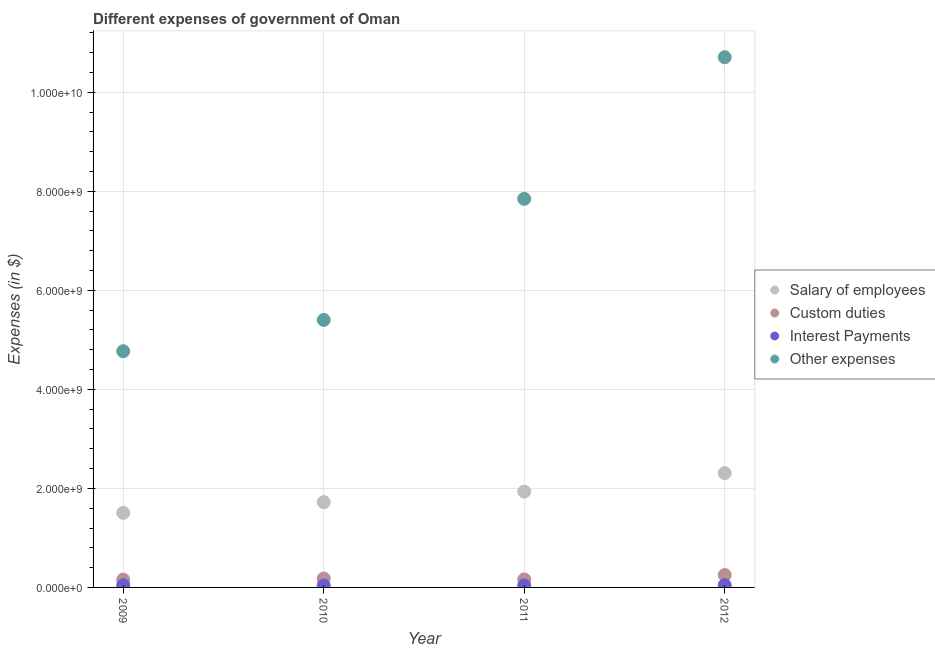How many different coloured dotlines are there?
Ensure brevity in your answer.  4. Is the number of dotlines equal to the number of legend labels?
Provide a succinct answer. Yes. What is the amount spent on custom duties in 2010?
Provide a succinct answer. 1.80e+08. Across all years, what is the maximum amount spent on interest payments?
Your answer should be compact. 4.53e+07. Across all years, what is the minimum amount spent on interest payments?
Your response must be concise. 3.74e+07. What is the total amount spent on salary of employees in the graph?
Provide a short and direct response. 7.47e+09. What is the difference between the amount spent on custom duties in 2011 and that in 2012?
Ensure brevity in your answer.  -8.89e+07. What is the difference between the amount spent on salary of employees in 2011 and the amount spent on custom duties in 2010?
Provide a short and direct response. 1.76e+09. What is the average amount spent on salary of employees per year?
Provide a succinct answer. 1.87e+09. In the year 2011, what is the difference between the amount spent on interest payments and amount spent on other expenses?
Your response must be concise. -7.81e+09. What is the ratio of the amount spent on salary of employees in 2009 to that in 2010?
Give a very brief answer. 0.87. What is the difference between the highest and the second highest amount spent on other expenses?
Provide a succinct answer. 2.86e+09. What is the difference between the highest and the lowest amount spent on salary of employees?
Your response must be concise. 8.01e+08. Is it the case that in every year, the sum of the amount spent on other expenses and amount spent on salary of employees is greater than the sum of amount spent on custom duties and amount spent on interest payments?
Your response must be concise. Yes. Is it the case that in every year, the sum of the amount spent on salary of employees and amount spent on custom duties is greater than the amount spent on interest payments?
Your answer should be very brief. Yes. Does the amount spent on interest payments monotonically increase over the years?
Offer a terse response. No. Is the amount spent on custom duties strictly greater than the amount spent on salary of employees over the years?
Provide a succinct answer. No. Is the amount spent on custom duties strictly less than the amount spent on salary of employees over the years?
Give a very brief answer. Yes. How many dotlines are there?
Make the answer very short. 4. What is the difference between two consecutive major ticks on the Y-axis?
Your answer should be compact. 2.00e+09. Are the values on the major ticks of Y-axis written in scientific E-notation?
Ensure brevity in your answer.  Yes. Does the graph contain any zero values?
Offer a terse response. No. Where does the legend appear in the graph?
Your answer should be very brief. Center right. How are the legend labels stacked?
Offer a very short reply. Vertical. What is the title of the graph?
Give a very brief answer. Different expenses of government of Oman. Does "Others" appear as one of the legend labels in the graph?
Your answer should be very brief. No. What is the label or title of the X-axis?
Ensure brevity in your answer.  Year. What is the label or title of the Y-axis?
Make the answer very short. Expenses (in $). What is the Expenses (in $) in Salary of employees in 2009?
Your answer should be compact. 1.51e+09. What is the Expenses (in $) in Custom duties in 2009?
Provide a succinct answer. 1.58e+08. What is the Expenses (in $) of Interest Payments in 2009?
Provide a short and direct response. 4.50e+07. What is the Expenses (in $) of Other expenses in 2009?
Keep it short and to the point. 4.77e+09. What is the Expenses (in $) in Salary of employees in 2010?
Give a very brief answer. 1.72e+09. What is the Expenses (in $) of Custom duties in 2010?
Your answer should be compact. 1.80e+08. What is the Expenses (in $) in Interest Payments in 2010?
Your answer should be compact. 3.74e+07. What is the Expenses (in $) of Other expenses in 2010?
Make the answer very short. 5.40e+09. What is the Expenses (in $) in Salary of employees in 2011?
Your answer should be compact. 1.94e+09. What is the Expenses (in $) in Custom duties in 2011?
Ensure brevity in your answer.  1.61e+08. What is the Expenses (in $) in Interest Payments in 2011?
Provide a short and direct response. 3.81e+07. What is the Expenses (in $) of Other expenses in 2011?
Give a very brief answer. 7.85e+09. What is the Expenses (in $) in Salary of employees in 2012?
Make the answer very short. 2.31e+09. What is the Expenses (in $) in Custom duties in 2012?
Your answer should be compact. 2.50e+08. What is the Expenses (in $) in Interest Payments in 2012?
Offer a very short reply. 4.53e+07. What is the Expenses (in $) of Other expenses in 2012?
Offer a very short reply. 1.07e+1. Across all years, what is the maximum Expenses (in $) of Salary of employees?
Keep it short and to the point. 2.31e+09. Across all years, what is the maximum Expenses (in $) of Custom duties?
Offer a terse response. 2.50e+08. Across all years, what is the maximum Expenses (in $) of Interest Payments?
Keep it short and to the point. 4.53e+07. Across all years, what is the maximum Expenses (in $) of Other expenses?
Your response must be concise. 1.07e+1. Across all years, what is the minimum Expenses (in $) in Salary of employees?
Your answer should be very brief. 1.51e+09. Across all years, what is the minimum Expenses (in $) in Custom duties?
Provide a short and direct response. 1.58e+08. Across all years, what is the minimum Expenses (in $) of Interest Payments?
Give a very brief answer. 3.74e+07. Across all years, what is the minimum Expenses (in $) in Other expenses?
Make the answer very short. 4.77e+09. What is the total Expenses (in $) of Salary of employees in the graph?
Your answer should be very brief. 7.47e+09. What is the total Expenses (in $) of Custom duties in the graph?
Give a very brief answer. 7.49e+08. What is the total Expenses (in $) in Interest Payments in the graph?
Keep it short and to the point. 1.66e+08. What is the total Expenses (in $) in Other expenses in the graph?
Offer a terse response. 2.87e+1. What is the difference between the Expenses (in $) of Salary of employees in 2009 and that in 2010?
Your answer should be compact. -2.16e+08. What is the difference between the Expenses (in $) in Custom duties in 2009 and that in 2010?
Make the answer very short. -2.15e+07. What is the difference between the Expenses (in $) of Interest Payments in 2009 and that in 2010?
Offer a very short reply. 7.60e+06. What is the difference between the Expenses (in $) in Other expenses in 2009 and that in 2010?
Ensure brevity in your answer.  -6.32e+08. What is the difference between the Expenses (in $) in Salary of employees in 2009 and that in 2011?
Keep it short and to the point. -4.29e+08. What is the difference between the Expenses (in $) in Custom duties in 2009 and that in 2011?
Your answer should be very brief. -3.10e+06. What is the difference between the Expenses (in $) of Interest Payments in 2009 and that in 2011?
Keep it short and to the point. 6.90e+06. What is the difference between the Expenses (in $) of Other expenses in 2009 and that in 2011?
Make the answer very short. -3.08e+09. What is the difference between the Expenses (in $) of Salary of employees in 2009 and that in 2012?
Make the answer very short. -8.01e+08. What is the difference between the Expenses (in $) in Custom duties in 2009 and that in 2012?
Your response must be concise. -9.20e+07. What is the difference between the Expenses (in $) of Other expenses in 2009 and that in 2012?
Provide a short and direct response. -5.94e+09. What is the difference between the Expenses (in $) in Salary of employees in 2010 and that in 2011?
Offer a very short reply. -2.13e+08. What is the difference between the Expenses (in $) in Custom duties in 2010 and that in 2011?
Make the answer very short. 1.84e+07. What is the difference between the Expenses (in $) in Interest Payments in 2010 and that in 2011?
Ensure brevity in your answer.  -7.00e+05. What is the difference between the Expenses (in $) in Other expenses in 2010 and that in 2011?
Make the answer very short. -2.45e+09. What is the difference between the Expenses (in $) of Salary of employees in 2010 and that in 2012?
Offer a terse response. -5.85e+08. What is the difference between the Expenses (in $) of Custom duties in 2010 and that in 2012?
Your response must be concise. -7.05e+07. What is the difference between the Expenses (in $) of Interest Payments in 2010 and that in 2012?
Your answer should be very brief. -7.90e+06. What is the difference between the Expenses (in $) in Other expenses in 2010 and that in 2012?
Ensure brevity in your answer.  -5.30e+09. What is the difference between the Expenses (in $) of Salary of employees in 2011 and that in 2012?
Provide a succinct answer. -3.72e+08. What is the difference between the Expenses (in $) in Custom duties in 2011 and that in 2012?
Offer a very short reply. -8.89e+07. What is the difference between the Expenses (in $) in Interest Payments in 2011 and that in 2012?
Provide a succinct answer. -7.20e+06. What is the difference between the Expenses (in $) in Other expenses in 2011 and that in 2012?
Offer a very short reply. -2.86e+09. What is the difference between the Expenses (in $) in Salary of employees in 2009 and the Expenses (in $) in Custom duties in 2010?
Offer a very short reply. 1.33e+09. What is the difference between the Expenses (in $) of Salary of employees in 2009 and the Expenses (in $) of Interest Payments in 2010?
Provide a short and direct response. 1.47e+09. What is the difference between the Expenses (in $) of Salary of employees in 2009 and the Expenses (in $) of Other expenses in 2010?
Make the answer very short. -3.90e+09. What is the difference between the Expenses (in $) in Custom duties in 2009 and the Expenses (in $) in Interest Payments in 2010?
Your answer should be compact. 1.21e+08. What is the difference between the Expenses (in $) of Custom duties in 2009 and the Expenses (in $) of Other expenses in 2010?
Your answer should be very brief. -5.24e+09. What is the difference between the Expenses (in $) of Interest Payments in 2009 and the Expenses (in $) of Other expenses in 2010?
Your answer should be compact. -5.36e+09. What is the difference between the Expenses (in $) of Salary of employees in 2009 and the Expenses (in $) of Custom duties in 2011?
Your answer should be compact. 1.35e+09. What is the difference between the Expenses (in $) of Salary of employees in 2009 and the Expenses (in $) of Interest Payments in 2011?
Offer a very short reply. 1.47e+09. What is the difference between the Expenses (in $) of Salary of employees in 2009 and the Expenses (in $) of Other expenses in 2011?
Your response must be concise. -6.34e+09. What is the difference between the Expenses (in $) of Custom duties in 2009 and the Expenses (in $) of Interest Payments in 2011?
Provide a short and direct response. 1.20e+08. What is the difference between the Expenses (in $) of Custom duties in 2009 and the Expenses (in $) of Other expenses in 2011?
Provide a succinct answer. -7.69e+09. What is the difference between the Expenses (in $) of Interest Payments in 2009 and the Expenses (in $) of Other expenses in 2011?
Your answer should be very brief. -7.80e+09. What is the difference between the Expenses (in $) in Salary of employees in 2009 and the Expenses (in $) in Custom duties in 2012?
Keep it short and to the point. 1.26e+09. What is the difference between the Expenses (in $) of Salary of employees in 2009 and the Expenses (in $) of Interest Payments in 2012?
Offer a very short reply. 1.46e+09. What is the difference between the Expenses (in $) in Salary of employees in 2009 and the Expenses (in $) in Other expenses in 2012?
Your response must be concise. -9.20e+09. What is the difference between the Expenses (in $) in Custom duties in 2009 and the Expenses (in $) in Interest Payments in 2012?
Offer a very short reply. 1.13e+08. What is the difference between the Expenses (in $) of Custom duties in 2009 and the Expenses (in $) of Other expenses in 2012?
Your answer should be very brief. -1.05e+1. What is the difference between the Expenses (in $) in Interest Payments in 2009 and the Expenses (in $) in Other expenses in 2012?
Keep it short and to the point. -1.07e+1. What is the difference between the Expenses (in $) in Salary of employees in 2010 and the Expenses (in $) in Custom duties in 2011?
Provide a short and direct response. 1.56e+09. What is the difference between the Expenses (in $) in Salary of employees in 2010 and the Expenses (in $) in Interest Payments in 2011?
Offer a terse response. 1.68e+09. What is the difference between the Expenses (in $) of Salary of employees in 2010 and the Expenses (in $) of Other expenses in 2011?
Make the answer very short. -6.12e+09. What is the difference between the Expenses (in $) in Custom duties in 2010 and the Expenses (in $) in Interest Payments in 2011?
Your response must be concise. 1.42e+08. What is the difference between the Expenses (in $) in Custom duties in 2010 and the Expenses (in $) in Other expenses in 2011?
Keep it short and to the point. -7.67e+09. What is the difference between the Expenses (in $) in Interest Payments in 2010 and the Expenses (in $) in Other expenses in 2011?
Offer a terse response. -7.81e+09. What is the difference between the Expenses (in $) in Salary of employees in 2010 and the Expenses (in $) in Custom duties in 2012?
Your answer should be compact. 1.47e+09. What is the difference between the Expenses (in $) in Salary of employees in 2010 and the Expenses (in $) in Interest Payments in 2012?
Offer a terse response. 1.68e+09. What is the difference between the Expenses (in $) in Salary of employees in 2010 and the Expenses (in $) in Other expenses in 2012?
Your answer should be very brief. -8.98e+09. What is the difference between the Expenses (in $) in Custom duties in 2010 and the Expenses (in $) in Interest Payments in 2012?
Provide a short and direct response. 1.34e+08. What is the difference between the Expenses (in $) in Custom duties in 2010 and the Expenses (in $) in Other expenses in 2012?
Make the answer very short. -1.05e+1. What is the difference between the Expenses (in $) of Interest Payments in 2010 and the Expenses (in $) of Other expenses in 2012?
Make the answer very short. -1.07e+1. What is the difference between the Expenses (in $) in Salary of employees in 2011 and the Expenses (in $) in Custom duties in 2012?
Your answer should be very brief. 1.69e+09. What is the difference between the Expenses (in $) of Salary of employees in 2011 and the Expenses (in $) of Interest Payments in 2012?
Keep it short and to the point. 1.89e+09. What is the difference between the Expenses (in $) in Salary of employees in 2011 and the Expenses (in $) in Other expenses in 2012?
Your response must be concise. -8.77e+09. What is the difference between the Expenses (in $) of Custom duties in 2011 and the Expenses (in $) of Interest Payments in 2012?
Your response must be concise. 1.16e+08. What is the difference between the Expenses (in $) of Custom duties in 2011 and the Expenses (in $) of Other expenses in 2012?
Ensure brevity in your answer.  -1.05e+1. What is the difference between the Expenses (in $) in Interest Payments in 2011 and the Expenses (in $) in Other expenses in 2012?
Make the answer very short. -1.07e+1. What is the average Expenses (in $) of Salary of employees per year?
Make the answer very short. 1.87e+09. What is the average Expenses (in $) in Custom duties per year?
Keep it short and to the point. 1.87e+08. What is the average Expenses (in $) in Interest Payments per year?
Your answer should be very brief. 4.14e+07. What is the average Expenses (in $) of Other expenses per year?
Ensure brevity in your answer.  7.18e+09. In the year 2009, what is the difference between the Expenses (in $) in Salary of employees and Expenses (in $) in Custom duties?
Keep it short and to the point. 1.35e+09. In the year 2009, what is the difference between the Expenses (in $) in Salary of employees and Expenses (in $) in Interest Payments?
Ensure brevity in your answer.  1.46e+09. In the year 2009, what is the difference between the Expenses (in $) of Salary of employees and Expenses (in $) of Other expenses?
Provide a succinct answer. -3.26e+09. In the year 2009, what is the difference between the Expenses (in $) of Custom duties and Expenses (in $) of Interest Payments?
Give a very brief answer. 1.13e+08. In the year 2009, what is the difference between the Expenses (in $) of Custom duties and Expenses (in $) of Other expenses?
Give a very brief answer. -4.61e+09. In the year 2009, what is the difference between the Expenses (in $) of Interest Payments and Expenses (in $) of Other expenses?
Ensure brevity in your answer.  -4.73e+09. In the year 2010, what is the difference between the Expenses (in $) in Salary of employees and Expenses (in $) in Custom duties?
Make the answer very short. 1.54e+09. In the year 2010, what is the difference between the Expenses (in $) of Salary of employees and Expenses (in $) of Interest Payments?
Provide a short and direct response. 1.69e+09. In the year 2010, what is the difference between the Expenses (in $) in Salary of employees and Expenses (in $) in Other expenses?
Offer a very short reply. -3.68e+09. In the year 2010, what is the difference between the Expenses (in $) of Custom duties and Expenses (in $) of Interest Payments?
Ensure brevity in your answer.  1.42e+08. In the year 2010, what is the difference between the Expenses (in $) of Custom duties and Expenses (in $) of Other expenses?
Offer a terse response. -5.22e+09. In the year 2010, what is the difference between the Expenses (in $) of Interest Payments and Expenses (in $) of Other expenses?
Provide a short and direct response. -5.36e+09. In the year 2011, what is the difference between the Expenses (in $) in Salary of employees and Expenses (in $) in Custom duties?
Provide a succinct answer. 1.77e+09. In the year 2011, what is the difference between the Expenses (in $) in Salary of employees and Expenses (in $) in Interest Payments?
Make the answer very short. 1.90e+09. In the year 2011, what is the difference between the Expenses (in $) of Salary of employees and Expenses (in $) of Other expenses?
Your answer should be compact. -5.91e+09. In the year 2011, what is the difference between the Expenses (in $) in Custom duties and Expenses (in $) in Interest Payments?
Your response must be concise. 1.23e+08. In the year 2011, what is the difference between the Expenses (in $) in Custom duties and Expenses (in $) in Other expenses?
Give a very brief answer. -7.69e+09. In the year 2011, what is the difference between the Expenses (in $) in Interest Payments and Expenses (in $) in Other expenses?
Ensure brevity in your answer.  -7.81e+09. In the year 2012, what is the difference between the Expenses (in $) in Salary of employees and Expenses (in $) in Custom duties?
Ensure brevity in your answer.  2.06e+09. In the year 2012, what is the difference between the Expenses (in $) in Salary of employees and Expenses (in $) in Interest Payments?
Your answer should be compact. 2.26e+09. In the year 2012, what is the difference between the Expenses (in $) in Salary of employees and Expenses (in $) in Other expenses?
Keep it short and to the point. -8.40e+09. In the year 2012, what is the difference between the Expenses (in $) of Custom duties and Expenses (in $) of Interest Payments?
Ensure brevity in your answer.  2.05e+08. In the year 2012, what is the difference between the Expenses (in $) in Custom duties and Expenses (in $) in Other expenses?
Provide a succinct answer. -1.05e+1. In the year 2012, what is the difference between the Expenses (in $) in Interest Payments and Expenses (in $) in Other expenses?
Your answer should be very brief. -1.07e+1. What is the ratio of the Expenses (in $) in Salary of employees in 2009 to that in 2010?
Your answer should be compact. 0.87. What is the ratio of the Expenses (in $) of Custom duties in 2009 to that in 2010?
Make the answer very short. 0.88. What is the ratio of the Expenses (in $) of Interest Payments in 2009 to that in 2010?
Give a very brief answer. 1.2. What is the ratio of the Expenses (in $) of Other expenses in 2009 to that in 2010?
Provide a succinct answer. 0.88. What is the ratio of the Expenses (in $) in Salary of employees in 2009 to that in 2011?
Offer a very short reply. 0.78. What is the ratio of the Expenses (in $) in Custom duties in 2009 to that in 2011?
Offer a very short reply. 0.98. What is the ratio of the Expenses (in $) of Interest Payments in 2009 to that in 2011?
Offer a terse response. 1.18. What is the ratio of the Expenses (in $) of Other expenses in 2009 to that in 2011?
Offer a very short reply. 0.61. What is the ratio of the Expenses (in $) in Salary of employees in 2009 to that in 2012?
Give a very brief answer. 0.65. What is the ratio of the Expenses (in $) in Custom duties in 2009 to that in 2012?
Offer a terse response. 0.63. What is the ratio of the Expenses (in $) in Other expenses in 2009 to that in 2012?
Provide a succinct answer. 0.45. What is the ratio of the Expenses (in $) of Salary of employees in 2010 to that in 2011?
Your answer should be very brief. 0.89. What is the ratio of the Expenses (in $) of Custom duties in 2010 to that in 2011?
Your response must be concise. 1.11. What is the ratio of the Expenses (in $) of Interest Payments in 2010 to that in 2011?
Give a very brief answer. 0.98. What is the ratio of the Expenses (in $) of Other expenses in 2010 to that in 2011?
Your response must be concise. 0.69. What is the ratio of the Expenses (in $) of Salary of employees in 2010 to that in 2012?
Ensure brevity in your answer.  0.75. What is the ratio of the Expenses (in $) in Custom duties in 2010 to that in 2012?
Provide a short and direct response. 0.72. What is the ratio of the Expenses (in $) of Interest Payments in 2010 to that in 2012?
Offer a terse response. 0.83. What is the ratio of the Expenses (in $) in Other expenses in 2010 to that in 2012?
Offer a terse response. 0.5. What is the ratio of the Expenses (in $) of Salary of employees in 2011 to that in 2012?
Your answer should be compact. 0.84. What is the ratio of the Expenses (in $) in Custom duties in 2011 to that in 2012?
Ensure brevity in your answer.  0.64. What is the ratio of the Expenses (in $) of Interest Payments in 2011 to that in 2012?
Make the answer very short. 0.84. What is the ratio of the Expenses (in $) in Other expenses in 2011 to that in 2012?
Offer a very short reply. 0.73. What is the difference between the highest and the second highest Expenses (in $) of Salary of employees?
Your response must be concise. 3.72e+08. What is the difference between the highest and the second highest Expenses (in $) in Custom duties?
Keep it short and to the point. 7.05e+07. What is the difference between the highest and the second highest Expenses (in $) in Other expenses?
Ensure brevity in your answer.  2.86e+09. What is the difference between the highest and the lowest Expenses (in $) in Salary of employees?
Give a very brief answer. 8.01e+08. What is the difference between the highest and the lowest Expenses (in $) of Custom duties?
Your answer should be very brief. 9.20e+07. What is the difference between the highest and the lowest Expenses (in $) of Interest Payments?
Give a very brief answer. 7.90e+06. What is the difference between the highest and the lowest Expenses (in $) of Other expenses?
Offer a very short reply. 5.94e+09. 